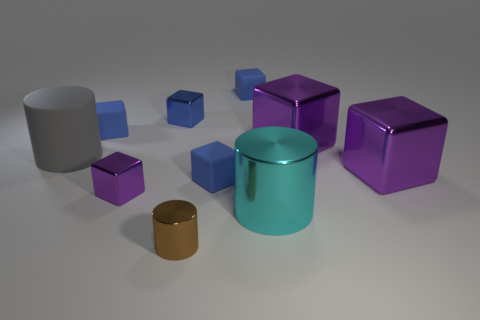Subtract all blue blocks. How many were subtracted if there are2blue blocks left? 2 Subtract all large cylinders. How many cylinders are left? 1 Subtract all blue blocks. How many blocks are left? 3 Subtract all cylinders. How many objects are left? 7 Subtract 1 cylinders. How many cylinders are left? 2 Subtract all yellow blocks. Subtract all red spheres. How many blocks are left? 7 Subtract all yellow spheres. How many brown cylinders are left? 1 Subtract all small purple metal cubes. Subtract all small brown objects. How many objects are left? 8 Add 4 large purple cubes. How many large purple cubes are left? 6 Add 8 small purple cubes. How many small purple cubes exist? 9 